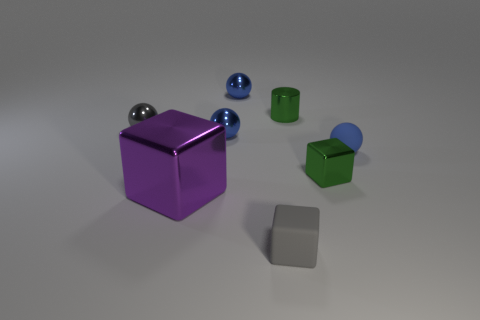The small rubber object that is the same shape as the small gray shiny thing is what color?
Ensure brevity in your answer.  Blue. Is there a green cube that has the same size as the blue matte ball?
Your answer should be compact. Yes. What is the color of the big metallic block?
Offer a terse response. Purple. There is a shiny block on the right side of the tiny ball behind the tiny metal cylinder; what color is it?
Keep it short and to the point. Green. What shape is the small blue metal object in front of the sphere to the left of the block to the left of the gray rubber object?
Offer a terse response. Sphere. What number of other small gray cylinders are made of the same material as the tiny cylinder?
Ensure brevity in your answer.  0. There is a green object in front of the green cylinder; what number of small blocks are in front of it?
Offer a terse response. 1. What number of blue metallic cylinders are there?
Your response must be concise. 0. Is the material of the large object the same as the gray object that is in front of the large purple thing?
Provide a short and direct response. No. Does the small thing that is behind the shiny cylinder have the same color as the small rubber sphere?
Give a very brief answer. Yes. 